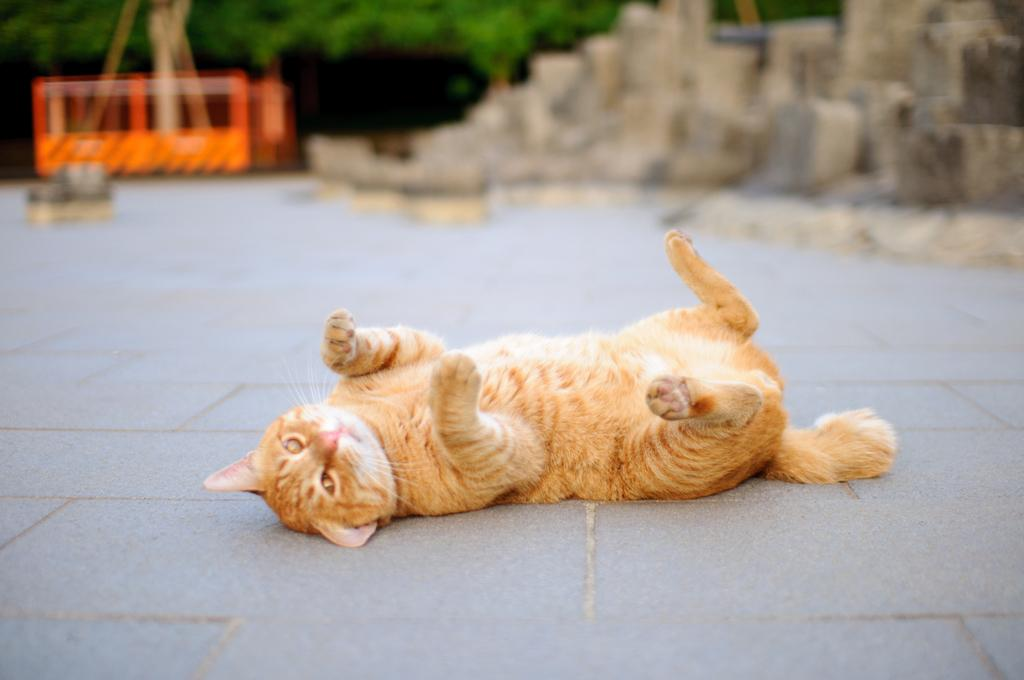What is the main subject in the center of the image? There is a cat in the center of the image. Where is the cat located? The cat is on the floor. What can be seen in the background of the image? There are trees and other objects in the background of the image. What type of cracker is the cat holding in its paw in the image? There is no cracker present in the image, and the cat is not holding anything in its paw. 